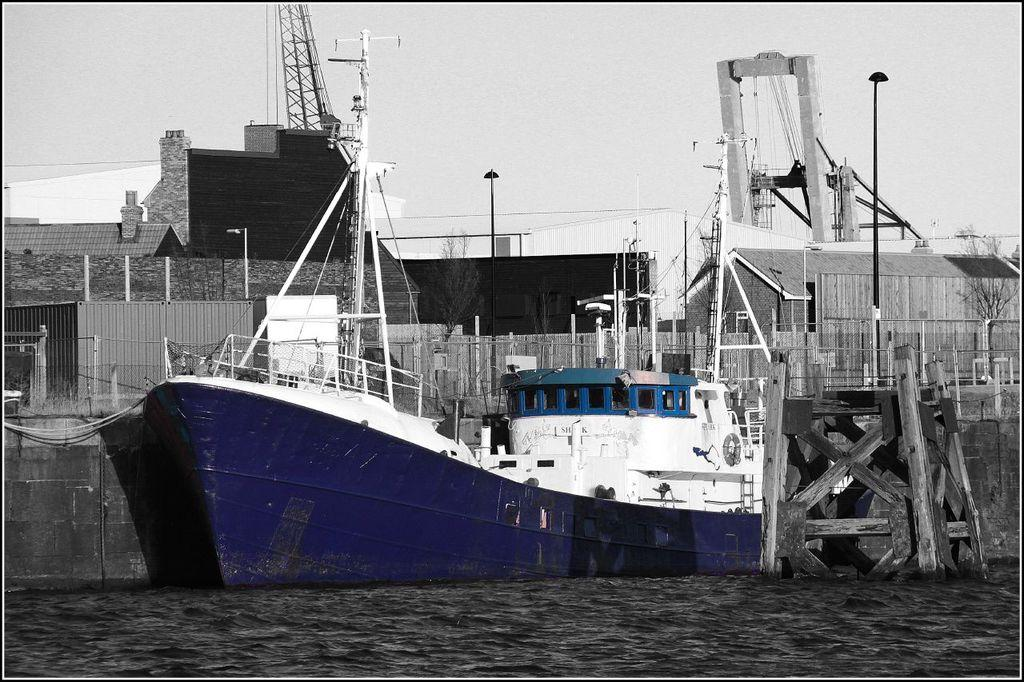What is the main subject of the image? There is a boat in the image. What is the boat doing in the image? The boat is sailing on the water. What can be seen in the background of the image? There are buildings, trees, and poles in the backdrop of the image. How is the sky depicted in the image? The sky is clear in the image. How many oranges are hanging from the poles in the image? There are no oranges present in the image; the poles are part of the backdrop and not associated with any fruit. What type of wave can be seen crashing against the boat in the image? There is no wave present in the image; the boat is sailing smoothly on calm water. 